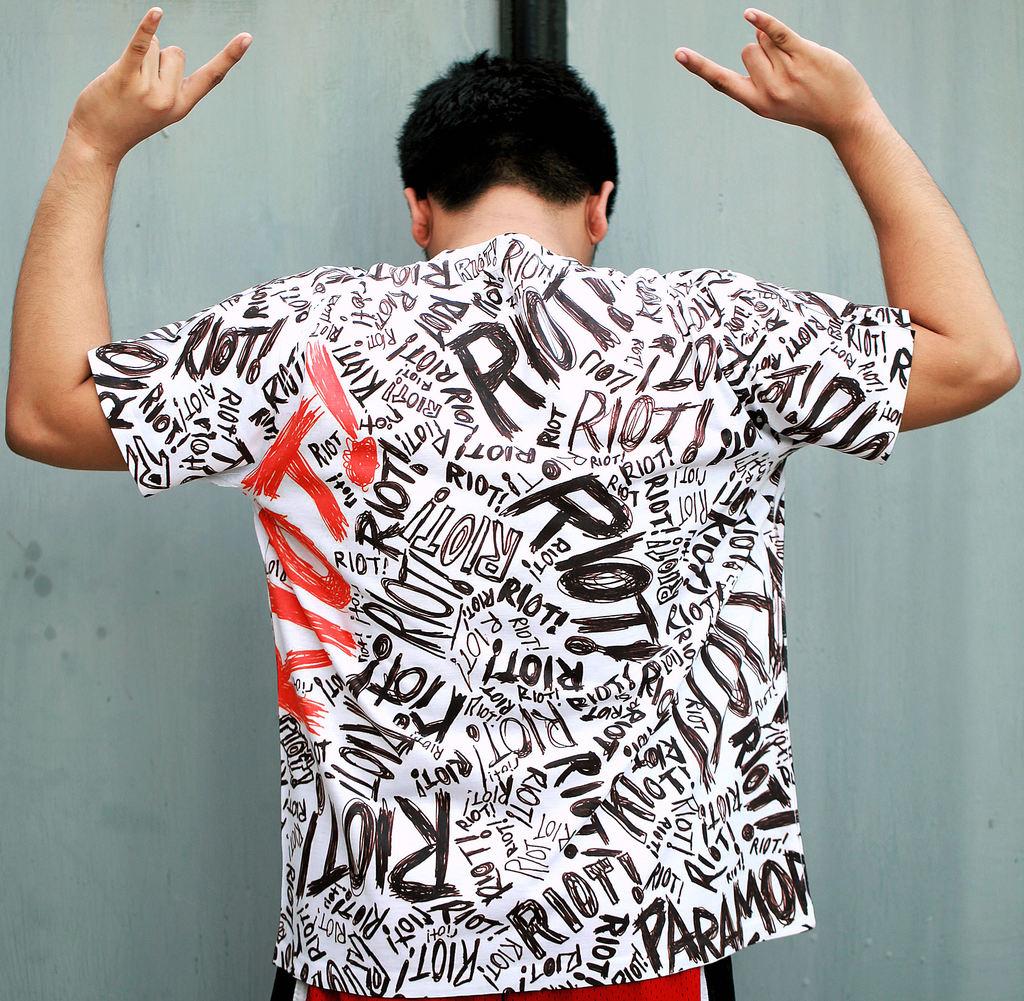What word is being repeated on the shirt?
Offer a very short reply. Riot. What is the most distinct word written on the t-shirt?
Keep it short and to the point. Riot. 